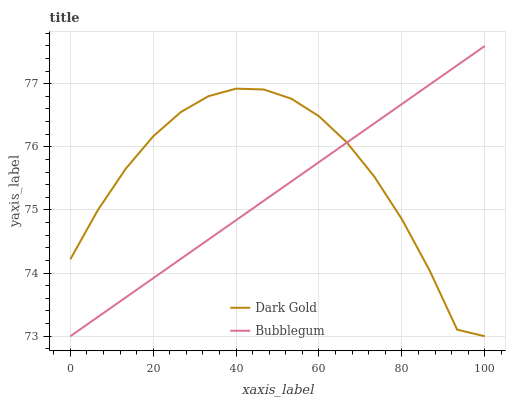Does Bubblegum have the minimum area under the curve?
Answer yes or no. Yes. Does Dark Gold have the maximum area under the curve?
Answer yes or no. Yes. Does Dark Gold have the minimum area under the curve?
Answer yes or no. No. Is Bubblegum the smoothest?
Answer yes or no. Yes. Is Dark Gold the roughest?
Answer yes or no. Yes. Is Dark Gold the smoothest?
Answer yes or no. No. Does Bubblegum have the lowest value?
Answer yes or no. Yes. Does Bubblegum have the highest value?
Answer yes or no. Yes. Does Dark Gold have the highest value?
Answer yes or no. No. Does Bubblegum intersect Dark Gold?
Answer yes or no. Yes. Is Bubblegum less than Dark Gold?
Answer yes or no. No. Is Bubblegum greater than Dark Gold?
Answer yes or no. No. 